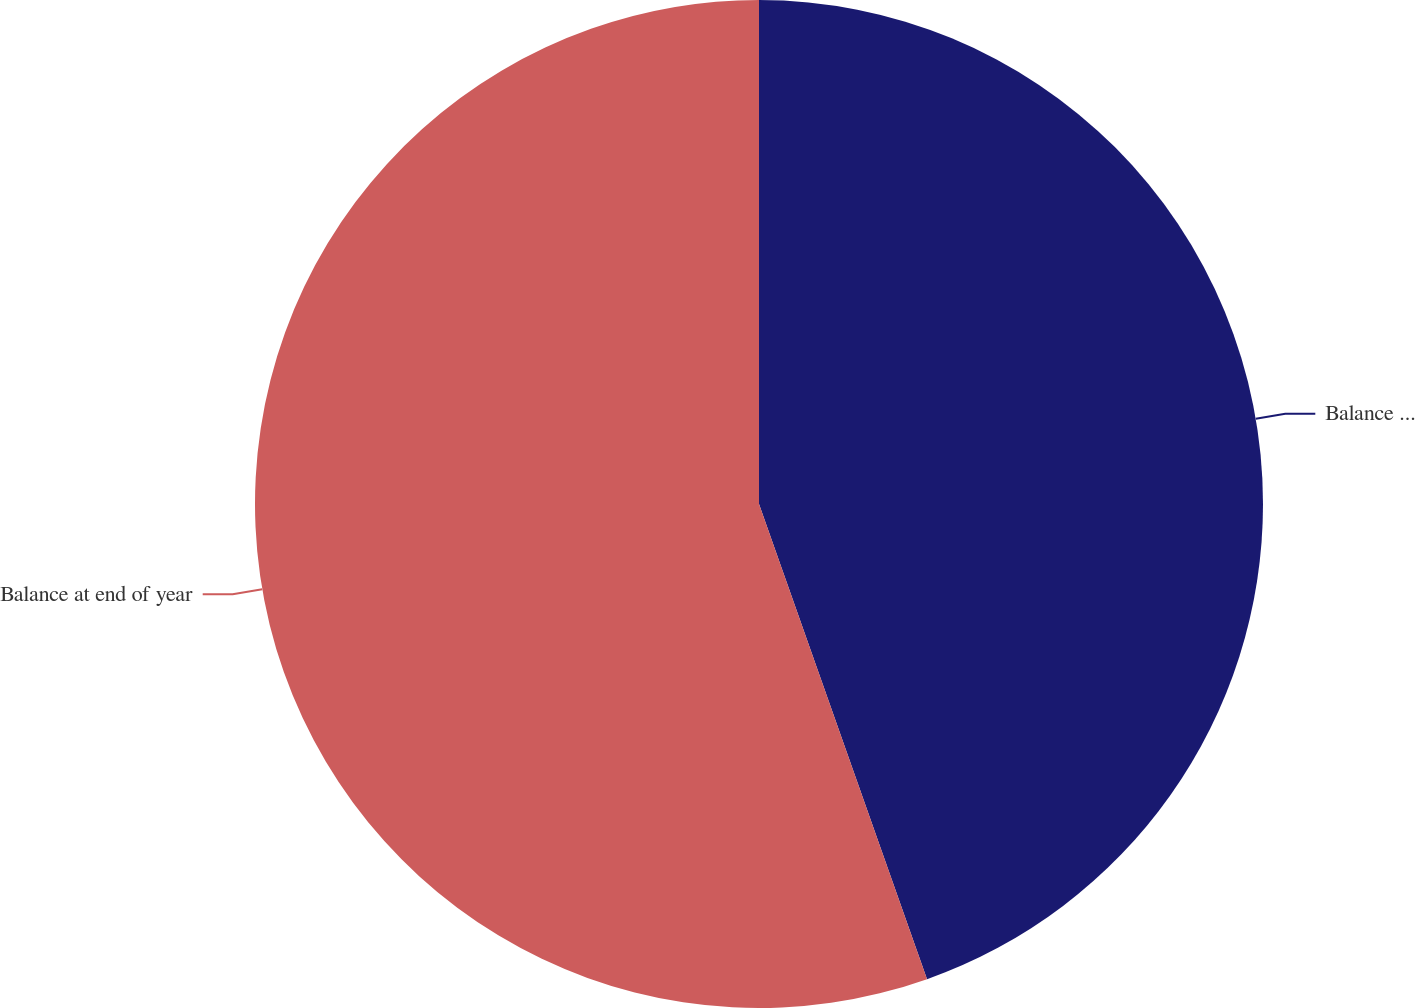Convert chart. <chart><loc_0><loc_0><loc_500><loc_500><pie_chart><fcel>Balance at beginning of year<fcel>Balance at end of year<nl><fcel>44.59%<fcel>55.41%<nl></chart> 